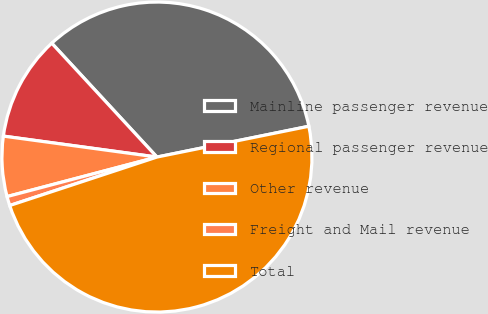<chart> <loc_0><loc_0><loc_500><loc_500><pie_chart><fcel>Mainline passenger revenue<fcel>Regional passenger revenue<fcel>Other revenue<fcel>Freight and Mail revenue<fcel>Total<nl><fcel>33.69%<fcel>10.97%<fcel>6.26%<fcel>0.96%<fcel>48.12%<nl></chart> 